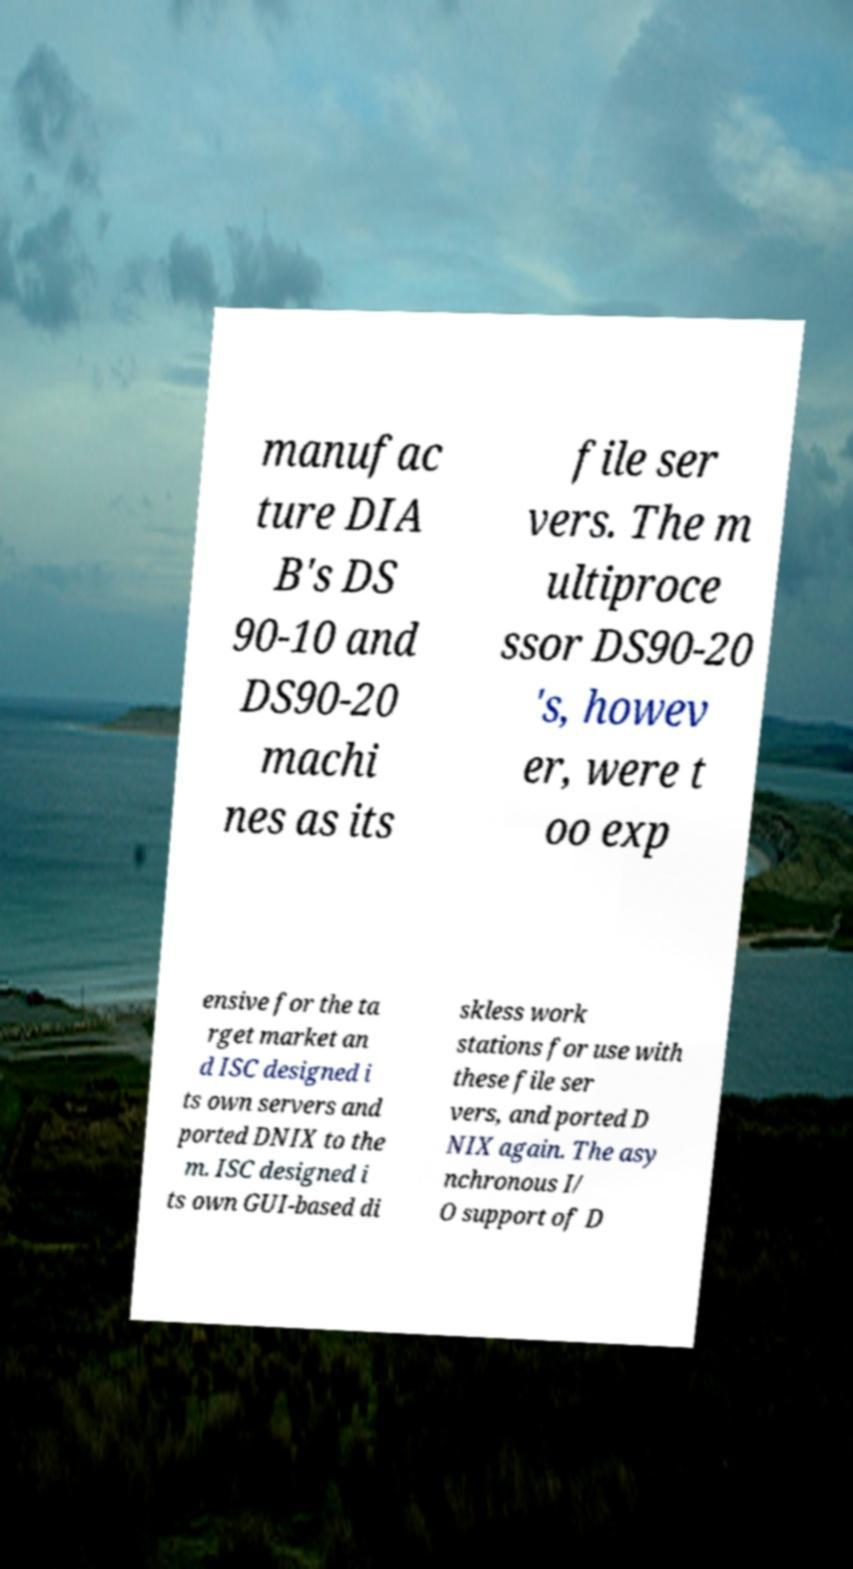I need the written content from this picture converted into text. Can you do that? manufac ture DIA B's DS 90-10 and DS90-20 machi nes as its file ser vers. The m ultiproce ssor DS90-20 's, howev er, were t oo exp ensive for the ta rget market an d ISC designed i ts own servers and ported DNIX to the m. ISC designed i ts own GUI-based di skless work stations for use with these file ser vers, and ported D NIX again. The asy nchronous I/ O support of D 